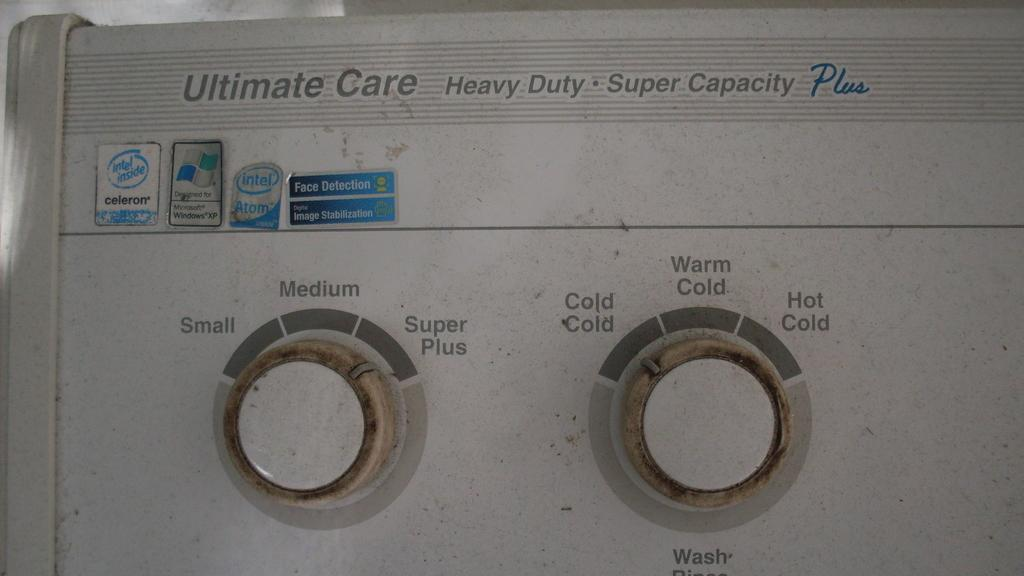What objects can be seen in the image? There are buttons in the image. What else is present in the image besides the buttons? There is text in the image. What type of education can be seen in the image? There is no reference to education in the image; it only contains buttons and text. 